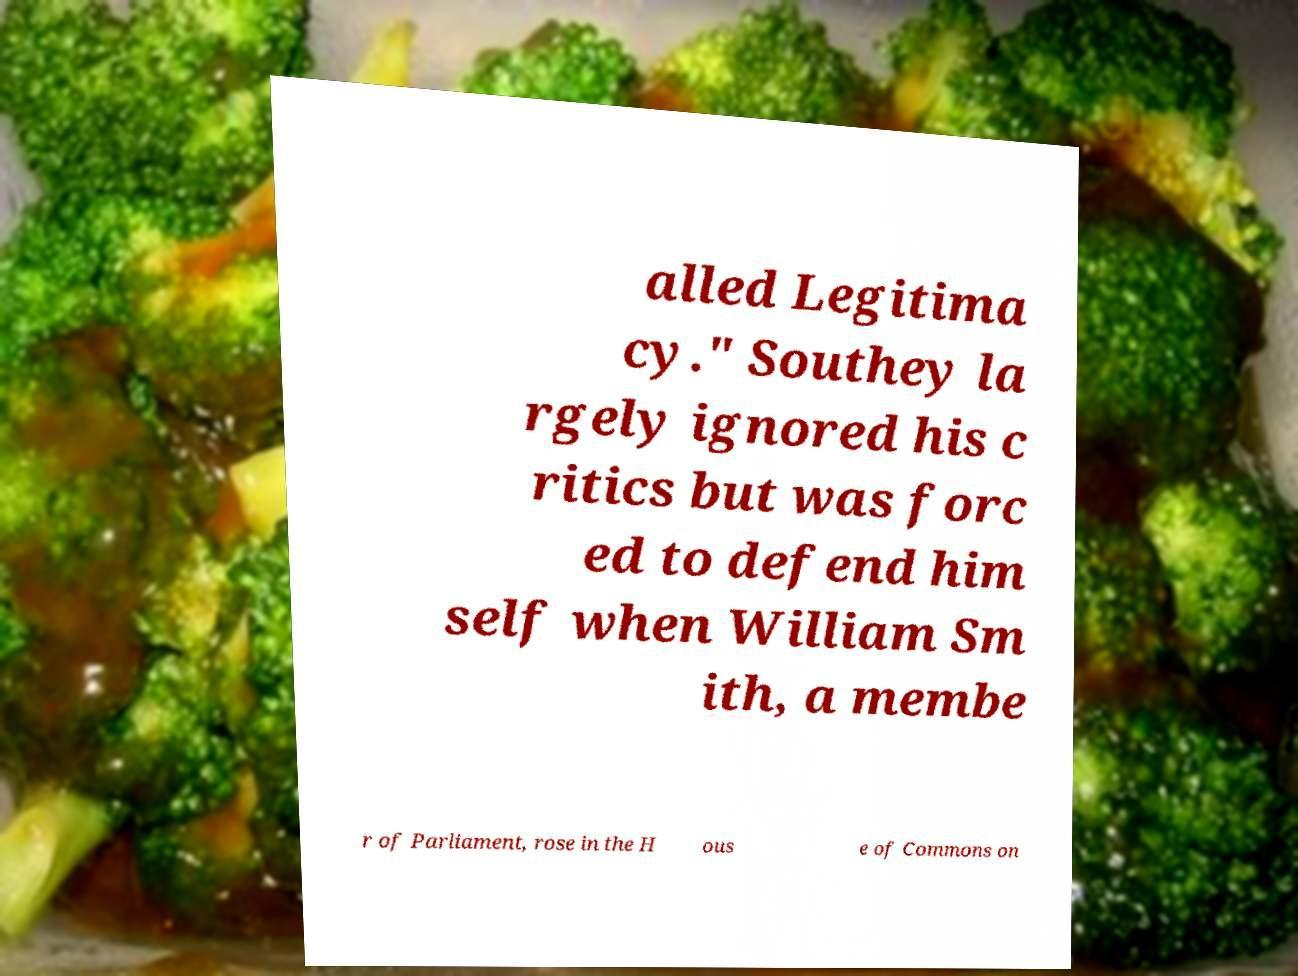Could you extract and type out the text from this image? alled Legitima cy." Southey la rgely ignored his c ritics but was forc ed to defend him self when William Sm ith, a membe r of Parliament, rose in the H ous e of Commons on 